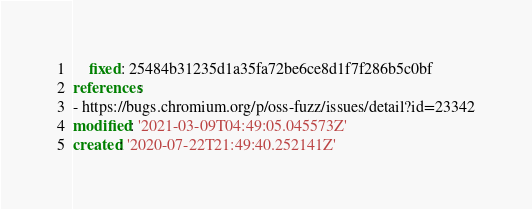Convert code to text. <code><loc_0><loc_0><loc_500><loc_500><_YAML_>    fixed: 25484b31235d1a35fa72be6ce8d1f7f286b5c0bf
references:
- https://bugs.chromium.org/p/oss-fuzz/issues/detail?id=23342
modified: '2021-03-09T04:49:05.045573Z'
created: '2020-07-22T21:49:40.252141Z'
</code> 